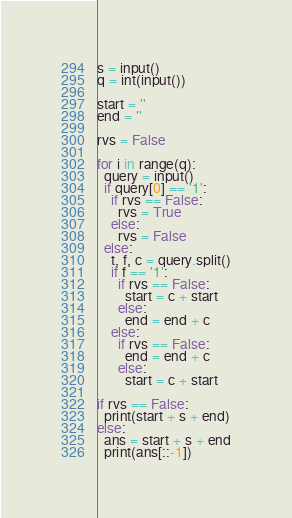<code> <loc_0><loc_0><loc_500><loc_500><_Python_>s = input()
q = int(input())

start = ''
end = ''

rvs = False

for i in range(q):
  query = input()
  if query[0] == '1':
    if rvs == False:
      rvs = True
    else:
      rvs = False
  else:
    t, f, c = query.split()
    if f == '1':
      if rvs == False:
        start = c + start
      else:
        end = end + c
    else:
      if rvs == False:
        end = end + c
      else:
        start = c + start

if rvs == False:
  print(start + s + end)
else:
  ans = start + s + end
  print(ans[::-1])</code> 